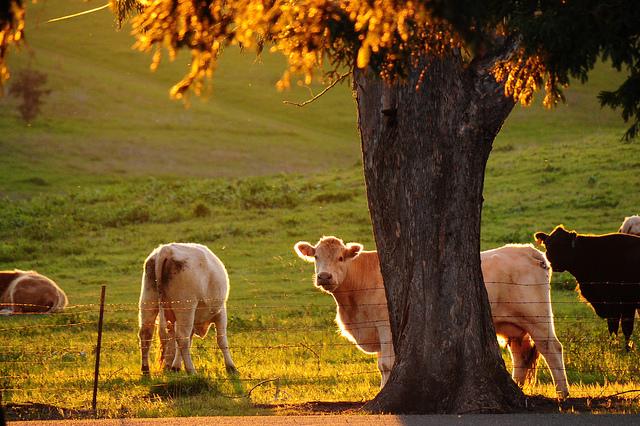How many cows are in the field?
Give a very brief answer. 5. What type of animal is this?
Concise answer only. Cow. What type of cows are they?
Be succinct. Dairy. Is the sun setting?
Give a very brief answer. Yes. Is a horse family?
Short answer required. No. 